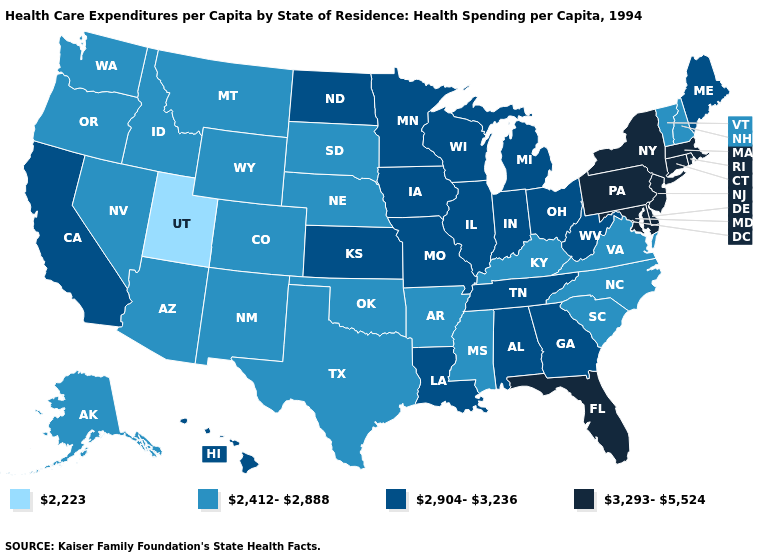Which states have the lowest value in the USA?
Concise answer only. Utah. Which states hav the highest value in the West?
Concise answer only. California, Hawaii. Which states hav the highest value in the South?
Be succinct. Delaware, Florida, Maryland. Among the states that border Nevada , which have the lowest value?
Answer briefly. Utah. Among the states that border New Mexico , which have the lowest value?
Be succinct. Utah. What is the lowest value in states that border Iowa?
Be succinct. 2,412-2,888. Which states hav the highest value in the South?
Give a very brief answer. Delaware, Florida, Maryland. Name the states that have a value in the range 2,904-3,236?
Short answer required. Alabama, California, Georgia, Hawaii, Illinois, Indiana, Iowa, Kansas, Louisiana, Maine, Michigan, Minnesota, Missouri, North Dakota, Ohio, Tennessee, West Virginia, Wisconsin. Does Utah have the lowest value in the USA?
Concise answer only. Yes. Name the states that have a value in the range 3,293-5,524?
Write a very short answer. Connecticut, Delaware, Florida, Maryland, Massachusetts, New Jersey, New York, Pennsylvania, Rhode Island. Does Vermont have the lowest value in the Northeast?
Give a very brief answer. Yes. What is the value of Iowa?
Quick response, please. 2,904-3,236. Which states have the lowest value in the South?
Keep it brief. Arkansas, Kentucky, Mississippi, North Carolina, Oklahoma, South Carolina, Texas, Virginia. What is the highest value in states that border Vermont?
Concise answer only. 3,293-5,524. What is the value of South Carolina?
Be succinct. 2,412-2,888. 